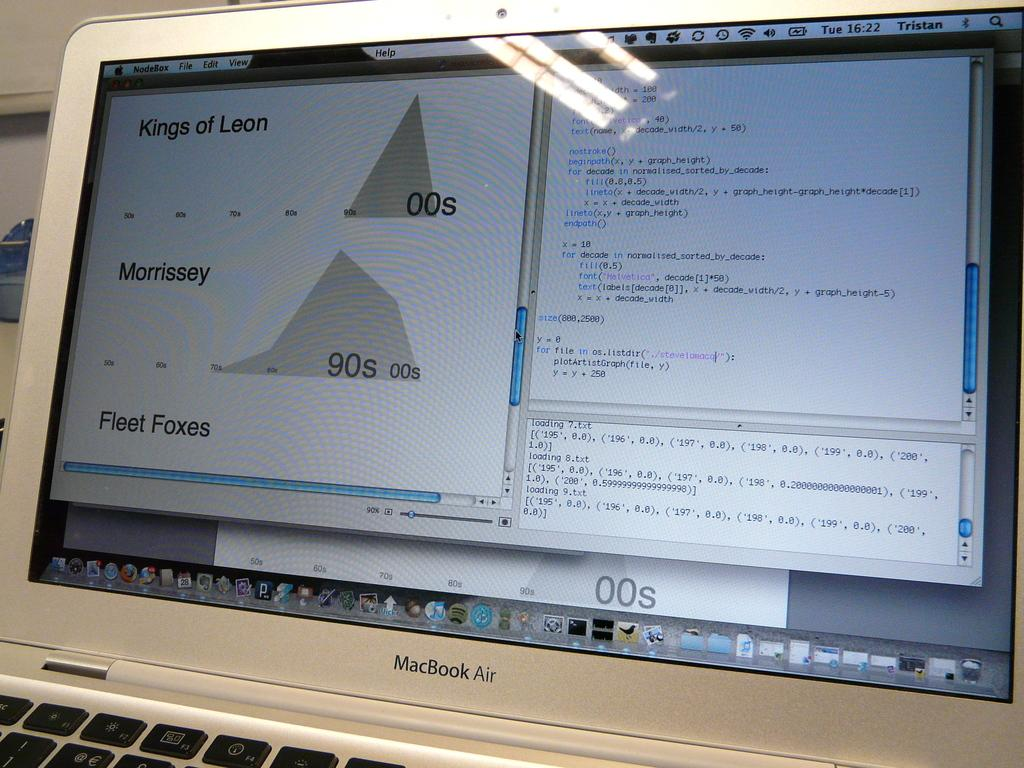<image>
Write a terse but informative summary of the picture. A computer shows a graph for Morrissey and Fleet Foxes. 